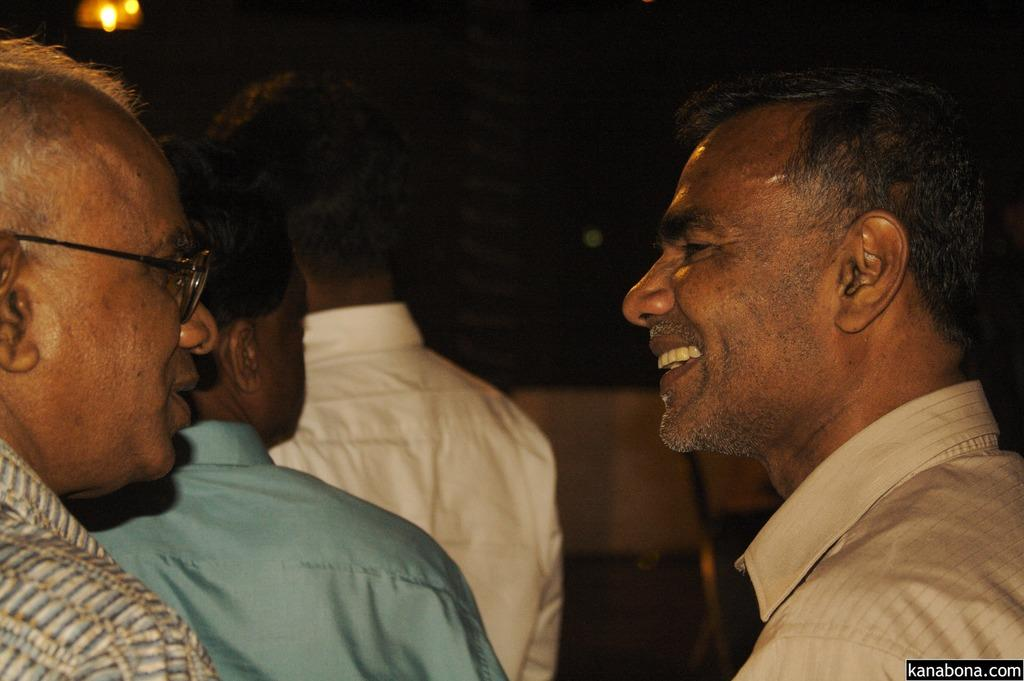What is the main subject of the image? The main subject of the image is a group of people. What are the people in the image doing? The people are standing in the image. What is the facial expression of the people in the image? The people are smiling in the image. What type of ticket can be seen in the hands of the people in the image? There is no ticket present in the image; it only shows a group of people standing and smiling. 